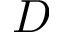<formula> <loc_0><loc_0><loc_500><loc_500>D</formula> 